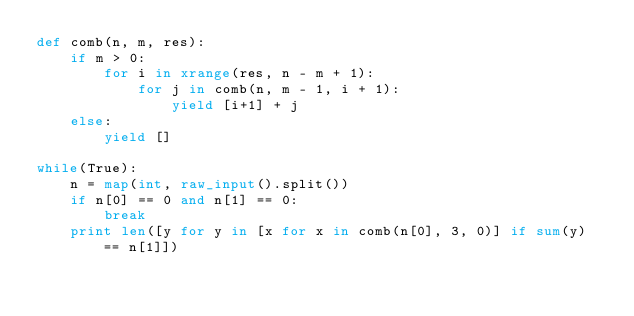Convert code to text. <code><loc_0><loc_0><loc_500><loc_500><_Python_>def comb(n, m, res):
    if m > 0:
        for i in xrange(res, n - m + 1):
            for j in comb(n, m - 1, i + 1):
                yield [i+1] + j
    else:
        yield []

while(True):
    n = map(int, raw_input().split())
    if n[0] == 0 and n[1] == 0:
        break
    print len([y for y in [x for x in comb(n[0], 3, 0)] if sum(y) == n[1]])</code> 